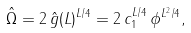<formula> <loc_0><loc_0><loc_500><loc_500>\hat { \Omega } = 2 \, \hat { g } ( L ) ^ { L / 4 } = 2 \, c _ { 1 } ^ { L / 4 } \, \phi ^ { L ^ { 2 } / 4 } ,</formula> 